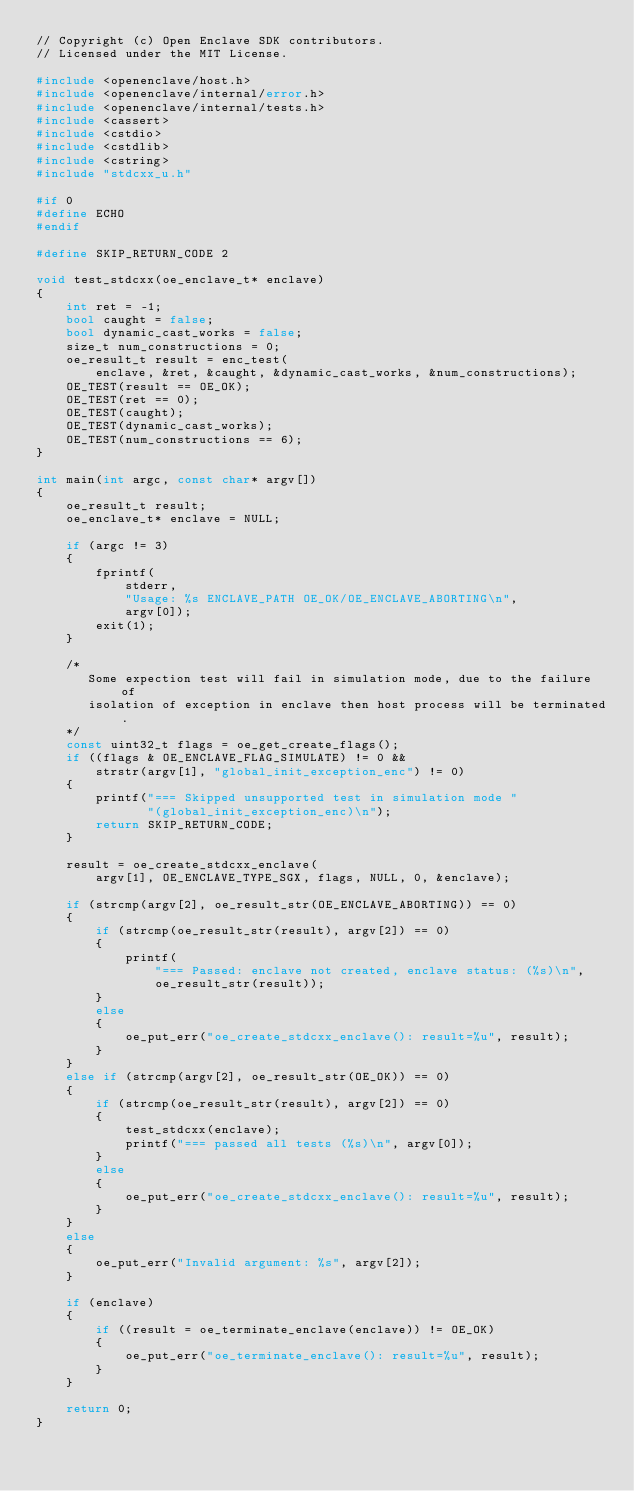Convert code to text. <code><loc_0><loc_0><loc_500><loc_500><_C++_>// Copyright (c) Open Enclave SDK contributors.
// Licensed under the MIT License.

#include <openenclave/host.h>
#include <openenclave/internal/error.h>
#include <openenclave/internal/tests.h>
#include <cassert>
#include <cstdio>
#include <cstdlib>
#include <cstring>
#include "stdcxx_u.h"

#if 0
#define ECHO
#endif

#define SKIP_RETURN_CODE 2

void test_stdcxx(oe_enclave_t* enclave)
{
    int ret = -1;
    bool caught = false;
    bool dynamic_cast_works = false;
    size_t num_constructions = 0;
    oe_result_t result = enc_test(
        enclave, &ret, &caught, &dynamic_cast_works, &num_constructions);
    OE_TEST(result == OE_OK);
    OE_TEST(ret == 0);
    OE_TEST(caught);
    OE_TEST(dynamic_cast_works);
    OE_TEST(num_constructions == 6);
}

int main(int argc, const char* argv[])
{
    oe_result_t result;
    oe_enclave_t* enclave = NULL;

    if (argc != 3)
    {
        fprintf(
            stderr,
            "Usage: %s ENCLAVE_PATH OE_OK/OE_ENCLAVE_ABORTING\n",
            argv[0]);
        exit(1);
    }

    /*
       Some expection test will fail in simulation mode, due to the failure of
       isolation of exception in enclave then host process will be terminated.
    */
    const uint32_t flags = oe_get_create_flags();
    if ((flags & OE_ENCLAVE_FLAG_SIMULATE) != 0 &&
        strstr(argv[1], "global_init_exception_enc") != 0)
    {
        printf("=== Skipped unsupported test in simulation mode "
               "(global_init_exception_enc)\n");
        return SKIP_RETURN_CODE;
    }

    result = oe_create_stdcxx_enclave(
        argv[1], OE_ENCLAVE_TYPE_SGX, flags, NULL, 0, &enclave);

    if (strcmp(argv[2], oe_result_str(OE_ENCLAVE_ABORTING)) == 0)
    {
        if (strcmp(oe_result_str(result), argv[2]) == 0)
        {
            printf(
                "=== Passed: enclave not created, enclave status: (%s)\n",
                oe_result_str(result));
        }
        else
        {
            oe_put_err("oe_create_stdcxx_enclave(): result=%u", result);
        }
    }
    else if (strcmp(argv[2], oe_result_str(OE_OK)) == 0)
    {
        if (strcmp(oe_result_str(result), argv[2]) == 0)
        {
            test_stdcxx(enclave);
            printf("=== passed all tests (%s)\n", argv[0]);
        }
        else
        {
            oe_put_err("oe_create_stdcxx_enclave(): result=%u", result);
        }
    }
    else
    {
        oe_put_err("Invalid argument: %s", argv[2]);
    }

    if (enclave)
    {
        if ((result = oe_terminate_enclave(enclave)) != OE_OK)
        {
            oe_put_err("oe_terminate_enclave(): result=%u", result);
        }
    }

    return 0;
}
</code> 